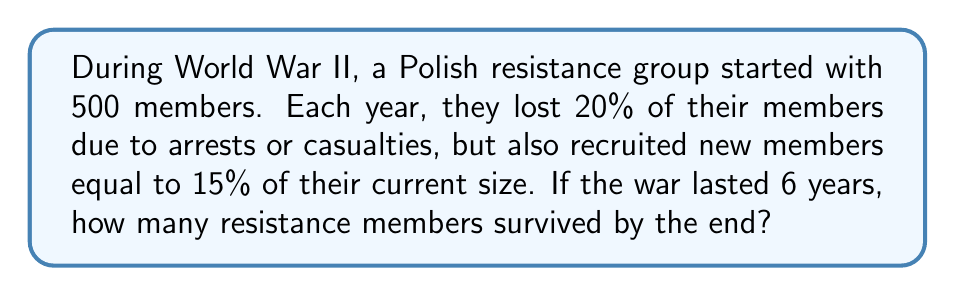Help me with this question. Let's approach this step-by-step:

1) Let $N_i$ be the number of members at the start of year $i$.

2) Each year, the group loses 20% and gains 15% of its current size. This means the group size is multiplied by $(1 - 0.20 + 0.15) = 0.95$ each year.

3) We can express this as a geometric sequence:

   $N_1 = 500$
   $N_2 = 500 \cdot 0.95$
   $N_3 = 500 \cdot 0.95^2$
   ...
   $N_6 = 500 \cdot 0.95^5$

4) The general formula for this sequence is:

   $N_i = 500 \cdot 0.95^{i-1}$

5) To find the number of survivors after 6 years, we calculate $N_6$:

   $N_6 = 500 \cdot 0.95^5$

6) Using a calculator or computer:

   $N_6 = 500 \cdot 0.95^5 \approx 386.65$

7) Since we can't have a fractional number of people, we round down to the nearest whole number.
Answer: 386 